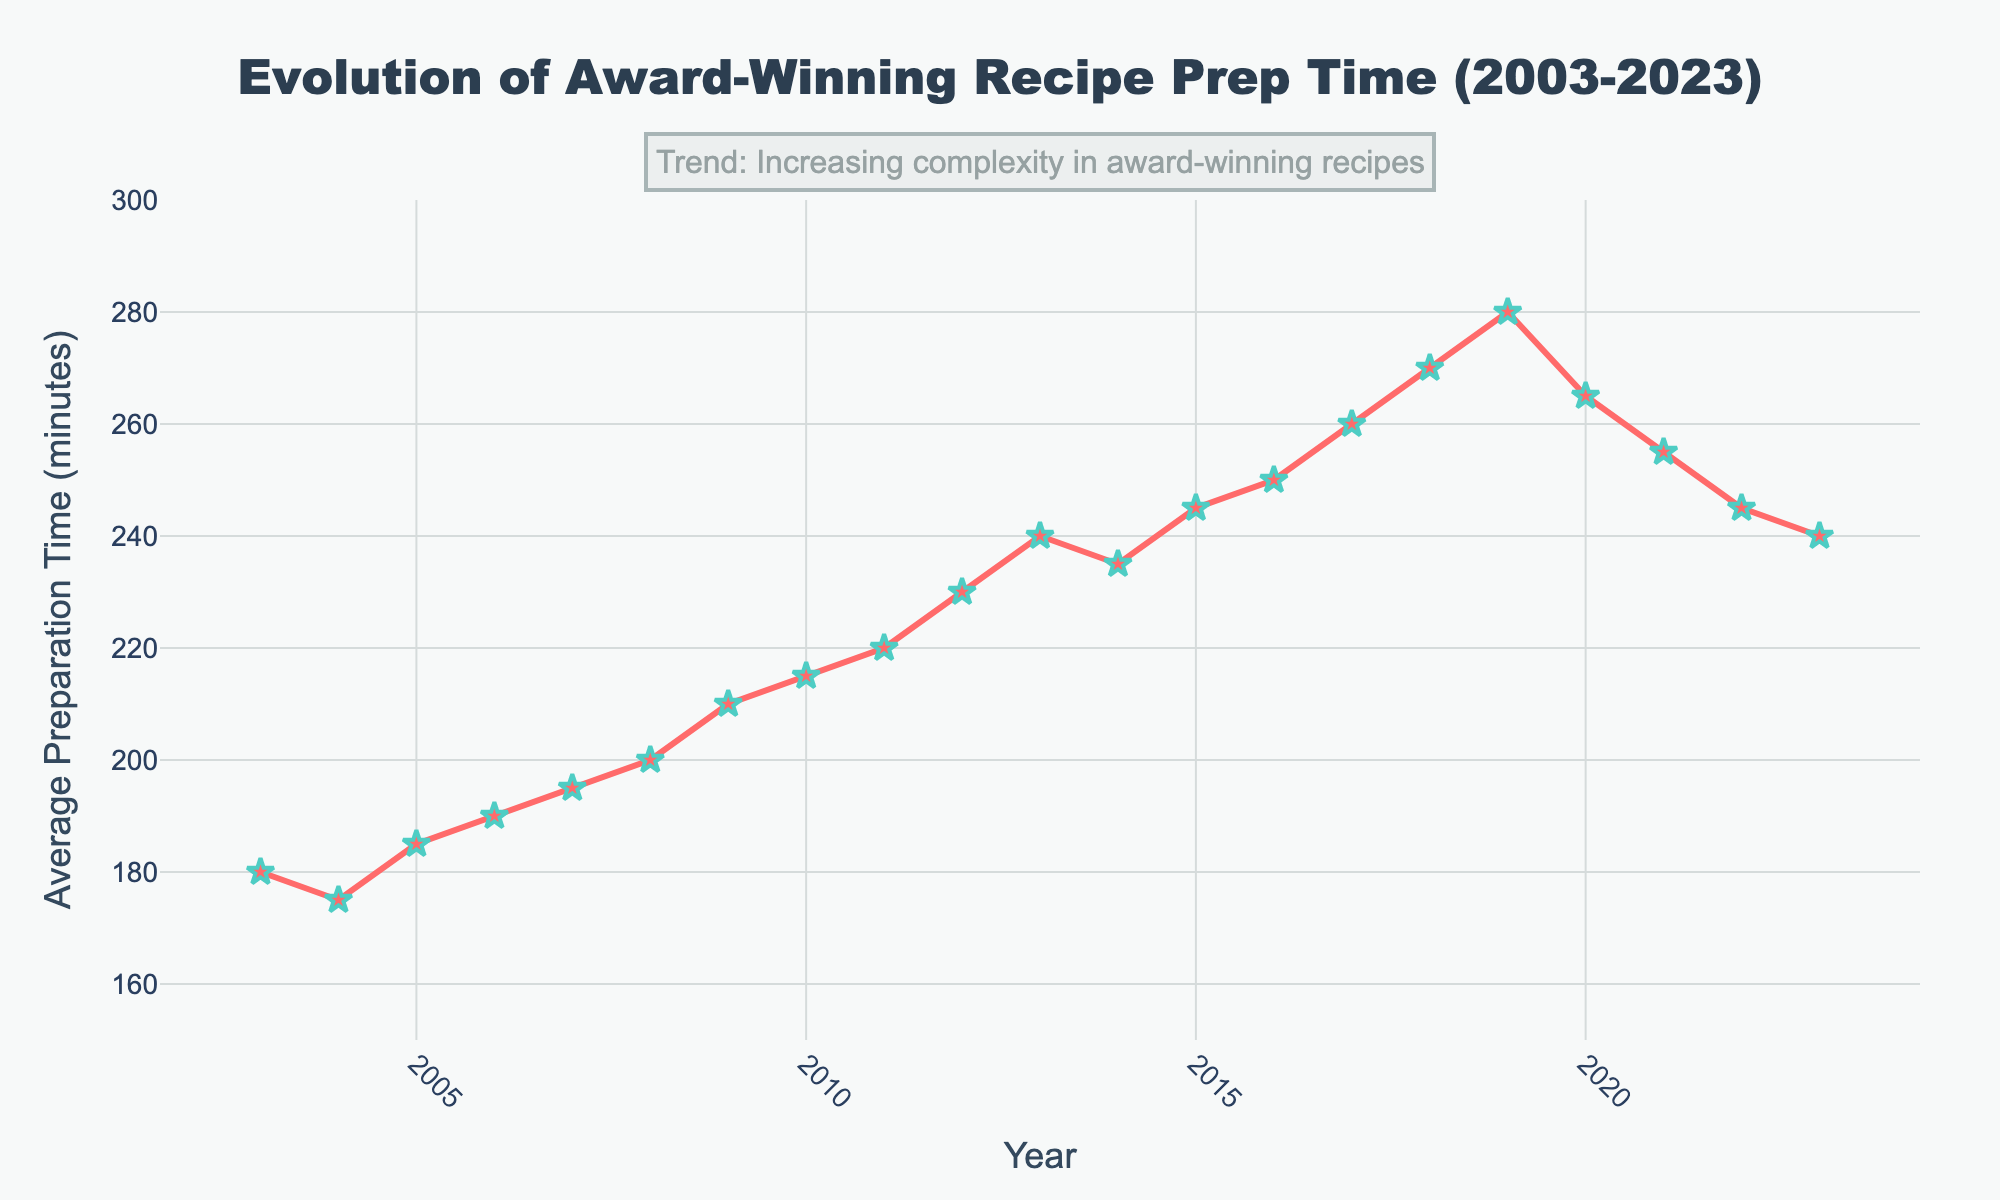What is the highest average preparation time recorded over the 20 years? To determine the highest average preparation time, we need to compare the values for all the years. The maximum value is seen in 2019, which is 280 minutes.
Answer: 280 minutes What is the average preparation time in 2023 compared to 2003? In 2023, the average preparation time is 240 minutes, while in 2003 it is 180 minutes. We can see that 240 minutes (2023) is greater than 180 minutes (2003).
Answer: Greater Between which consecutive years did the average preparation time increase the most? By comparing the year-over-year changes, the most significant increase is between 2018 and 2019, where the average preparation time increased from 270 minutes to 280 minutes (a 10-minute increase).
Answer: 2018 to 2019 By how many minutes did the average preparation time decrease from 2019 to 2020? The average preparation time in 2019 is 280 minutes and in 2020 it is 265 minutes. The difference is 280 - 265 = 15 minutes.
Answer: 15 minutes What was the average preparation time trend between 2003 and 2023? To determine the trend, we look at the general direction of the data points from start to finish. The average preparation time increased overall from 180 minutes in 2003 to 240 minutes in 2023.
Answer: Increasing How many times did the average preparation time decrease from one year to the next over the 20 years? We need to count the years where the average preparation time drops compared to the previous year. Decreases happened in the years 2004, 2014, 2020, 2021, 2022, and 2023, totaling 6 times.
Answer: 6 times What was the average preparation time in 2010? By looking at the data for 2010, we see that the average preparation time is 215 minutes.
Answer: 215 minutes What is the difference in average preparation time between 2008 and 2015? The average preparation time in 2008 is 200 minutes. In 2015, it is 245 minutes. The difference is 245 - 200 = 45 minutes.
Answer: 45 minutes During what year did the average preparation time first exceed 200 minutes? Reviewing the data year by year, the preparation time first exceeds 200 minutes in 2009, where it reached 210 minutes.
Answer: 2009 